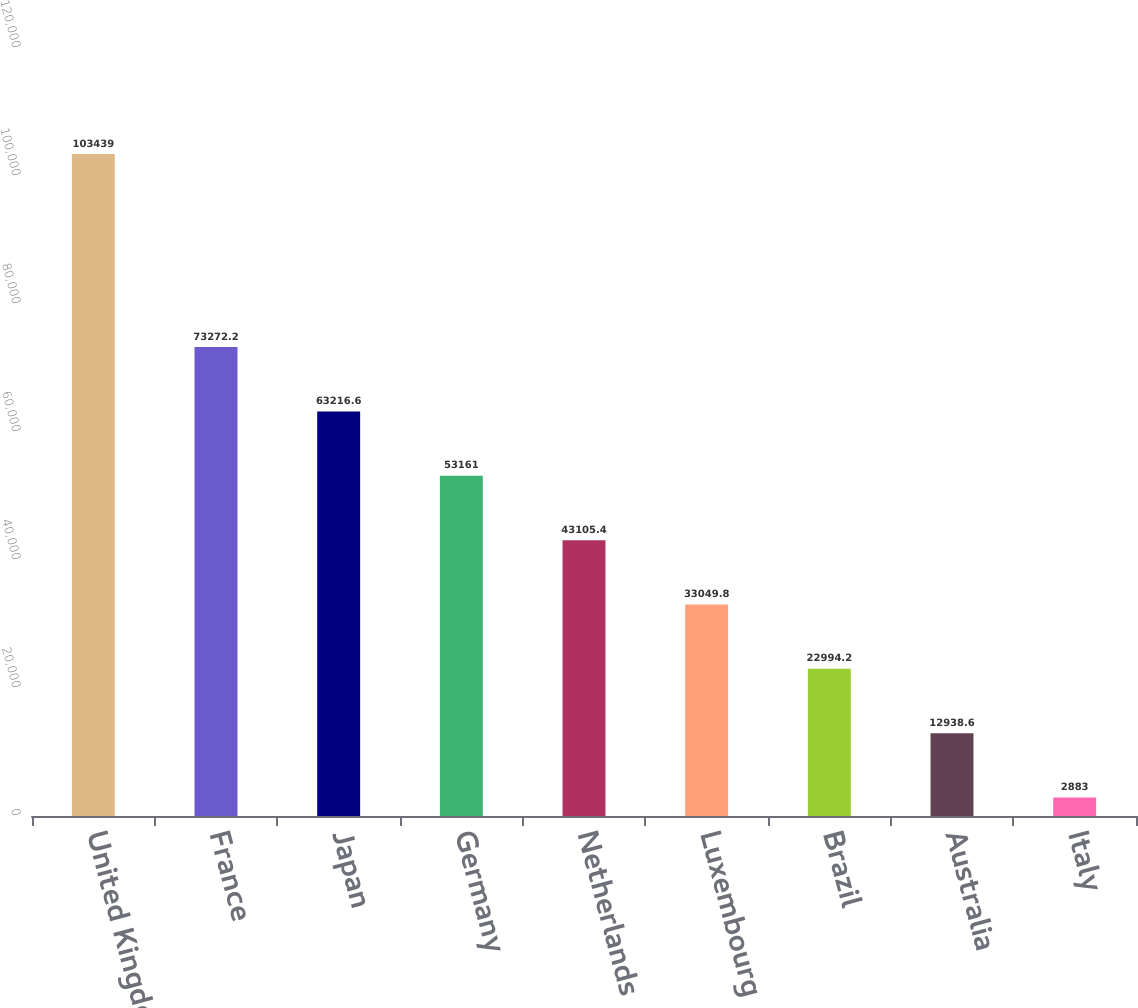Convert chart. <chart><loc_0><loc_0><loc_500><loc_500><bar_chart><fcel>United Kingdom<fcel>France<fcel>Japan<fcel>Germany<fcel>Netherlands<fcel>Luxembourg<fcel>Brazil<fcel>Australia<fcel>Italy<nl><fcel>103439<fcel>73272.2<fcel>63216.6<fcel>53161<fcel>43105.4<fcel>33049.8<fcel>22994.2<fcel>12938.6<fcel>2883<nl></chart> 